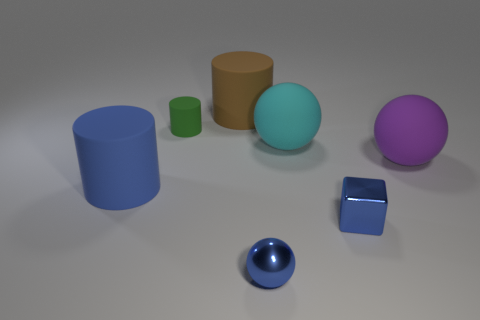Add 3 tiny brown matte spheres. How many objects exist? 10 Subtract all cubes. How many objects are left? 6 Add 5 green matte objects. How many green matte objects are left? 6 Add 3 blue matte things. How many blue matte things exist? 4 Subtract 0 gray cylinders. How many objects are left? 7 Subtract all small metal objects. Subtract all large purple things. How many objects are left? 4 